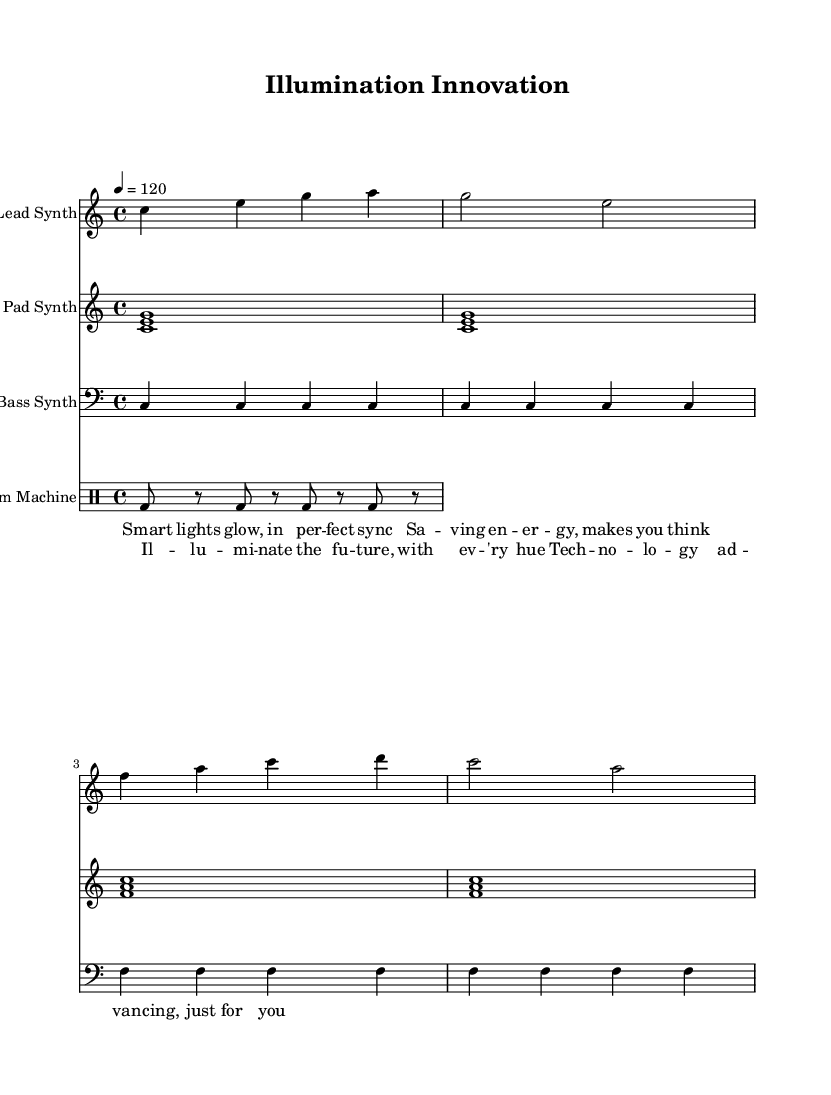What is the key signature of this music? The key signature is C major, which has no sharps or flats.
Answer: C major What is the time signature of this music? The time signature is determined by the notation at the beginning of the music, specifically the "4/4" present in the score.
Answer: 4/4 What is the tempo marking given in the score? The tempo is indicated by the notation "4 = 120," which means 120 beats per minute for each quarter note.
Answer: 120 How many measures are in the lead synth part? By counting the segments of the lead synth part, it consists of four measures based on the notation.
Answer: 4 What is the main theme expressed in the lyrics? The lyrics revolve around technological advancements and energy savings associated with smart lighting, emphasizing future innovation.
Answer: Smart lighting What type of instrument is the "Drum Machine" considered in this score? The "Drum Machine" is classified as a percussion instrument, shown in its own designated staff and using a specific drumming notation.
Answer: Percussion What is the rhythmic pattern in the drum machine part? The drum machine part consists of a consistent rhythm represented by the eighth note bass drum hits interspersed with rests, creating a steady pulse.
Answer: Eighth notes 